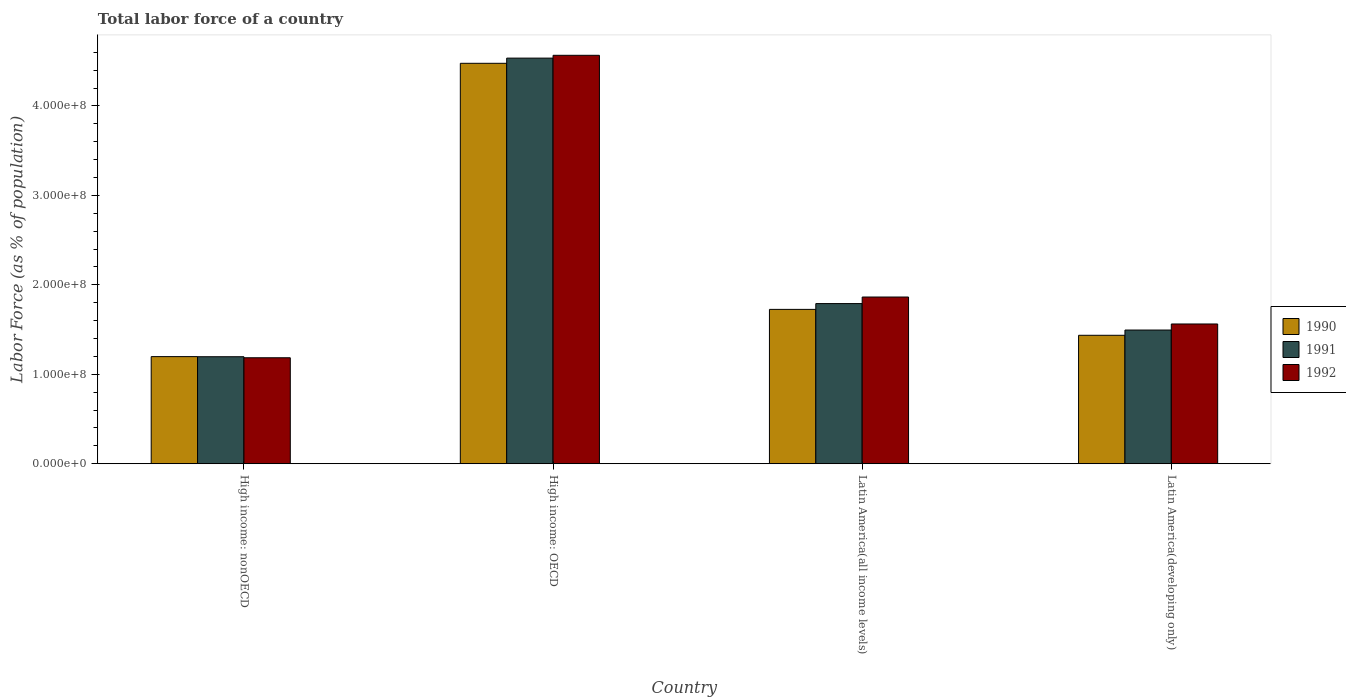How many groups of bars are there?
Your answer should be compact. 4. Are the number of bars per tick equal to the number of legend labels?
Provide a succinct answer. Yes. Are the number of bars on each tick of the X-axis equal?
Your answer should be compact. Yes. What is the label of the 1st group of bars from the left?
Your response must be concise. High income: nonOECD. What is the percentage of labor force in 1992 in Latin America(all income levels)?
Ensure brevity in your answer.  1.86e+08. Across all countries, what is the maximum percentage of labor force in 1990?
Offer a very short reply. 4.48e+08. Across all countries, what is the minimum percentage of labor force in 1992?
Provide a short and direct response. 1.18e+08. In which country was the percentage of labor force in 1991 maximum?
Ensure brevity in your answer.  High income: OECD. In which country was the percentage of labor force in 1992 minimum?
Offer a very short reply. High income: nonOECD. What is the total percentage of labor force in 1992 in the graph?
Ensure brevity in your answer.  9.18e+08. What is the difference between the percentage of labor force in 1991 in High income: OECD and that in Latin America(developing only)?
Keep it short and to the point. 3.04e+08. What is the difference between the percentage of labor force in 1990 in Latin America(all income levels) and the percentage of labor force in 1991 in High income: OECD?
Your answer should be very brief. -2.81e+08. What is the average percentage of labor force in 1991 per country?
Give a very brief answer. 2.25e+08. What is the difference between the percentage of labor force of/in 1991 and percentage of labor force of/in 1992 in High income: OECD?
Ensure brevity in your answer.  -3.15e+06. What is the ratio of the percentage of labor force in 1992 in Latin America(all income levels) to that in Latin America(developing only)?
Your answer should be compact. 1.19. Is the percentage of labor force in 1990 in High income: nonOECD less than that in Latin America(all income levels)?
Your answer should be very brief. Yes. What is the difference between the highest and the second highest percentage of labor force in 1991?
Provide a succinct answer. 3.04e+08. What is the difference between the highest and the lowest percentage of labor force in 1990?
Your response must be concise. 3.28e+08. In how many countries, is the percentage of labor force in 1990 greater than the average percentage of labor force in 1990 taken over all countries?
Keep it short and to the point. 1. Is the sum of the percentage of labor force in 1990 in High income: nonOECD and Latin America(all income levels) greater than the maximum percentage of labor force in 1992 across all countries?
Give a very brief answer. No. What does the 2nd bar from the left in Latin America(developing only) represents?
Your answer should be very brief. 1991. What does the 3rd bar from the right in High income: OECD represents?
Provide a succinct answer. 1990. Is it the case that in every country, the sum of the percentage of labor force in 1990 and percentage of labor force in 1991 is greater than the percentage of labor force in 1992?
Your answer should be compact. Yes. How many bars are there?
Offer a very short reply. 12. Are all the bars in the graph horizontal?
Offer a very short reply. No. How many countries are there in the graph?
Offer a terse response. 4. Are the values on the major ticks of Y-axis written in scientific E-notation?
Provide a succinct answer. Yes. Where does the legend appear in the graph?
Your answer should be very brief. Center right. How many legend labels are there?
Offer a terse response. 3. What is the title of the graph?
Your response must be concise. Total labor force of a country. Does "1964" appear as one of the legend labels in the graph?
Offer a very short reply. No. What is the label or title of the X-axis?
Your answer should be very brief. Country. What is the label or title of the Y-axis?
Your response must be concise. Labor Force (as % of population). What is the Labor Force (as % of population) in 1990 in High income: nonOECD?
Offer a terse response. 1.20e+08. What is the Labor Force (as % of population) of 1991 in High income: nonOECD?
Give a very brief answer. 1.20e+08. What is the Labor Force (as % of population) of 1992 in High income: nonOECD?
Your response must be concise. 1.18e+08. What is the Labor Force (as % of population) in 1990 in High income: OECD?
Offer a very short reply. 4.48e+08. What is the Labor Force (as % of population) of 1991 in High income: OECD?
Your answer should be very brief. 4.53e+08. What is the Labor Force (as % of population) in 1992 in High income: OECD?
Your answer should be very brief. 4.57e+08. What is the Labor Force (as % of population) of 1990 in Latin America(all income levels)?
Ensure brevity in your answer.  1.73e+08. What is the Labor Force (as % of population) of 1991 in Latin America(all income levels)?
Offer a terse response. 1.79e+08. What is the Labor Force (as % of population) in 1992 in Latin America(all income levels)?
Provide a short and direct response. 1.86e+08. What is the Labor Force (as % of population) of 1990 in Latin America(developing only)?
Your answer should be very brief. 1.44e+08. What is the Labor Force (as % of population) in 1991 in Latin America(developing only)?
Make the answer very short. 1.49e+08. What is the Labor Force (as % of population) in 1992 in Latin America(developing only)?
Keep it short and to the point. 1.56e+08. Across all countries, what is the maximum Labor Force (as % of population) in 1990?
Ensure brevity in your answer.  4.48e+08. Across all countries, what is the maximum Labor Force (as % of population) of 1991?
Provide a succinct answer. 4.53e+08. Across all countries, what is the maximum Labor Force (as % of population) of 1992?
Your response must be concise. 4.57e+08. Across all countries, what is the minimum Labor Force (as % of population) of 1990?
Provide a short and direct response. 1.20e+08. Across all countries, what is the minimum Labor Force (as % of population) of 1991?
Give a very brief answer. 1.20e+08. Across all countries, what is the minimum Labor Force (as % of population) of 1992?
Keep it short and to the point. 1.18e+08. What is the total Labor Force (as % of population) in 1990 in the graph?
Provide a succinct answer. 8.84e+08. What is the total Labor Force (as % of population) of 1991 in the graph?
Give a very brief answer. 9.02e+08. What is the total Labor Force (as % of population) of 1992 in the graph?
Your answer should be compact. 9.18e+08. What is the difference between the Labor Force (as % of population) in 1990 in High income: nonOECD and that in High income: OECD?
Offer a very short reply. -3.28e+08. What is the difference between the Labor Force (as % of population) in 1991 in High income: nonOECD and that in High income: OECD?
Provide a short and direct response. -3.34e+08. What is the difference between the Labor Force (as % of population) of 1992 in High income: nonOECD and that in High income: OECD?
Your response must be concise. -3.38e+08. What is the difference between the Labor Force (as % of population) of 1990 in High income: nonOECD and that in Latin America(all income levels)?
Your response must be concise. -5.28e+07. What is the difference between the Labor Force (as % of population) of 1991 in High income: nonOECD and that in Latin America(all income levels)?
Offer a very short reply. -5.94e+07. What is the difference between the Labor Force (as % of population) in 1992 in High income: nonOECD and that in Latin America(all income levels)?
Provide a succinct answer. -6.79e+07. What is the difference between the Labor Force (as % of population) in 1990 in High income: nonOECD and that in Latin America(developing only)?
Offer a very short reply. -2.38e+07. What is the difference between the Labor Force (as % of population) in 1991 in High income: nonOECD and that in Latin America(developing only)?
Your answer should be compact. -2.98e+07. What is the difference between the Labor Force (as % of population) in 1992 in High income: nonOECD and that in Latin America(developing only)?
Your answer should be compact. -3.78e+07. What is the difference between the Labor Force (as % of population) of 1990 in High income: OECD and that in Latin America(all income levels)?
Your answer should be compact. 2.75e+08. What is the difference between the Labor Force (as % of population) in 1991 in High income: OECD and that in Latin America(all income levels)?
Your response must be concise. 2.74e+08. What is the difference between the Labor Force (as % of population) in 1992 in High income: OECD and that in Latin America(all income levels)?
Your response must be concise. 2.70e+08. What is the difference between the Labor Force (as % of population) of 1990 in High income: OECD and that in Latin America(developing only)?
Ensure brevity in your answer.  3.04e+08. What is the difference between the Labor Force (as % of population) in 1991 in High income: OECD and that in Latin America(developing only)?
Ensure brevity in your answer.  3.04e+08. What is the difference between the Labor Force (as % of population) of 1992 in High income: OECD and that in Latin America(developing only)?
Your response must be concise. 3.00e+08. What is the difference between the Labor Force (as % of population) in 1990 in Latin America(all income levels) and that in Latin America(developing only)?
Make the answer very short. 2.90e+07. What is the difference between the Labor Force (as % of population) of 1991 in Latin America(all income levels) and that in Latin America(developing only)?
Provide a succinct answer. 2.96e+07. What is the difference between the Labor Force (as % of population) in 1992 in Latin America(all income levels) and that in Latin America(developing only)?
Your answer should be compact. 3.01e+07. What is the difference between the Labor Force (as % of population) in 1990 in High income: nonOECD and the Labor Force (as % of population) in 1991 in High income: OECD?
Offer a terse response. -3.34e+08. What is the difference between the Labor Force (as % of population) of 1990 in High income: nonOECD and the Labor Force (as % of population) of 1992 in High income: OECD?
Ensure brevity in your answer.  -3.37e+08. What is the difference between the Labor Force (as % of population) in 1991 in High income: nonOECD and the Labor Force (as % of population) in 1992 in High income: OECD?
Provide a short and direct response. -3.37e+08. What is the difference between the Labor Force (as % of population) of 1990 in High income: nonOECD and the Labor Force (as % of population) of 1991 in Latin America(all income levels)?
Your answer should be very brief. -5.93e+07. What is the difference between the Labor Force (as % of population) of 1990 in High income: nonOECD and the Labor Force (as % of population) of 1992 in Latin America(all income levels)?
Your answer should be very brief. -6.66e+07. What is the difference between the Labor Force (as % of population) of 1991 in High income: nonOECD and the Labor Force (as % of population) of 1992 in Latin America(all income levels)?
Your response must be concise. -6.67e+07. What is the difference between the Labor Force (as % of population) of 1990 in High income: nonOECD and the Labor Force (as % of population) of 1991 in Latin America(developing only)?
Offer a very short reply. -2.97e+07. What is the difference between the Labor Force (as % of population) of 1990 in High income: nonOECD and the Labor Force (as % of population) of 1992 in Latin America(developing only)?
Keep it short and to the point. -3.65e+07. What is the difference between the Labor Force (as % of population) in 1991 in High income: nonOECD and the Labor Force (as % of population) in 1992 in Latin America(developing only)?
Make the answer very short. -3.66e+07. What is the difference between the Labor Force (as % of population) of 1990 in High income: OECD and the Labor Force (as % of population) of 1991 in Latin America(all income levels)?
Provide a succinct answer. 2.69e+08. What is the difference between the Labor Force (as % of population) of 1990 in High income: OECD and the Labor Force (as % of population) of 1992 in Latin America(all income levels)?
Provide a succinct answer. 2.61e+08. What is the difference between the Labor Force (as % of population) in 1991 in High income: OECD and the Labor Force (as % of population) in 1992 in Latin America(all income levels)?
Provide a short and direct response. 2.67e+08. What is the difference between the Labor Force (as % of population) of 1990 in High income: OECD and the Labor Force (as % of population) of 1991 in Latin America(developing only)?
Offer a very short reply. 2.98e+08. What is the difference between the Labor Force (as % of population) of 1990 in High income: OECD and the Labor Force (as % of population) of 1992 in Latin America(developing only)?
Keep it short and to the point. 2.91e+08. What is the difference between the Labor Force (as % of population) in 1991 in High income: OECD and the Labor Force (as % of population) in 1992 in Latin America(developing only)?
Your response must be concise. 2.97e+08. What is the difference between the Labor Force (as % of population) of 1990 in Latin America(all income levels) and the Labor Force (as % of population) of 1991 in Latin America(developing only)?
Give a very brief answer. 2.31e+07. What is the difference between the Labor Force (as % of population) of 1990 in Latin America(all income levels) and the Labor Force (as % of population) of 1992 in Latin America(developing only)?
Provide a succinct answer. 1.63e+07. What is the difference between the Labor Force (as % of population) in 1991 in Latin America(all income levels) and the Labor Force (as % of population) in 1992 in Latin America(developing only)?
Offer a terse response. 2.28e+07. What is the average Labor Force (as % of population) in 1990 per country?
Your response must be concise. 2.21e+08. What is the average Labor Force (as % of population) in 1991 per country?
Provide a succinct answer. 2.25e+08. What is the average Labor Force (as % of population) in 1992 per country?
Make the answer very short. 2.29e+08. What is the difference between the Labor Force (as % of population) of 1990 and Labor Force (as % of population) of 1991 in High income: nonOECD?
Your response must be concise. 1.23e+05. What is the difference between the Labor Force (as % of population) in 1990 and Labor Force (as % of population) in 1992 in High income: nonOECD?
Make the answer very short. 1.27e+06. What is the difference between the Labor Force (as % of population) of 1991 and Labor Force (as % of population) of 1992 in High income: nonOECD?
Provide a short and direct response. 1.15e+06. What is the difference between the Labor Force (as % of population) in 1990 and Labor Force (as % of population) in 1991 in High income: OECD?
Ensure brevity in your answer.  -5.80e+06. What is the difference between the Labor Force (as % of population) of 1990 and Labor Force (as % of population) of 1992 in High income: OECD?
Provide a succinct answer. -8.94e+06. What is the difference between the Labor Force (as % of population) of 1991 and Labor Force (as % of population) of 1992 in High income: OECD?
Provide a succinct answer. -3.15e+06. What is the difference between the Labor Force (as % of population) of 1990 and Labor Force (as % of population) of 1991 in Latin America(all income levels)?
Your answer should be compact. -6.48e+06. What is the difference between the Labor Force (as % of population) of 1990 and Labor Force (as % of population) of 1992 in Latin America(all income levels)?
Offer a very short reply. -1.38e+07. What is the difference between the Labor Force (as % of population) of 1991 and Labor Force (as % of population) of 1992 in Latin America(all income levels)?
Give a very brief answer. -7.34e+06. What is the difference between the Labor Force (as % of population) of 1990 and Labor Force (as % of population) of 1991 in Latin America(developing only)?
Keep it short and to the point. -5.88e+06. What is the difference between the Labor Force (as % of population) in 1990 and Labor Force (as % of population) in 1992 in Latin America(developing only)?
Offer a terse response. -1.26e+07. What is the difference between the Labor Force (as % of population) of 1991 and Labor Force (as % of population) of 1992 in Latin America(developing only)?
Your answer should be compact. -6.77e+06. What is the ratio of the Labor Force (as % of population) of 1990 in High income: nonOECD to that in High income: OECD?
Make the answer very short. 0.27. What is the ratio of the Labor Force (as % of population) in 1991 in High income: nonOECD to that in High income: OECD?
Provide a succinct answer. 0.26. What is the ratio of the Labor Force (as % of population) in 1992 in High income: nonOECD to that in High income: OECD?
Your answer should be compact. 0.26. What is the ratio of the Labor Force (as % of population) of 1990 in High income: nonOECD to that in Latin America(all income levels)?
Give a very brief answer. 0.69. What is the ratio of the Labor Force (as % of population) in 1991 in High income: nonOECD to that in Latin America(all income levels)?
Your response must be concise. 0.67. What is the ratio of the Labor Force (as % of population) of 1992 in High income: nonOECD to that in Latin America(all income levels)?
Your answer should be compact. 0.64. What is the ratio of the Labor Force (as % of population) of 1990 in High income: nonOECD to that in Latin America(developing only)?
Your answer should be compact. 0.83. What is the ratio of the Labor Force (as % of population) in 1991 in High income: nonOECD to that in Latin America(developing only)?
Give a very brief answer. 0.8. What is the ratio of the Labor Force (as % of population) in 1992 in High income: nonOECD to that in Latin America(developing only)?
Keep it short and to the point. 0.76. What is the ratio of the Labor Force (as % of population) of 1990 in High income: OECD to that in Latin America(all income levels)?
Offer a very short reply. 2.59. What is the ratio of the Labor Force (as % of population) in 1991 in High income: OECD to that in Latin America(all income levels)?
Keep it short and to the point. 2.53. What is the ratio of the Labor Force (as % of population) in 1992 in High income: OECD to that in Latin America(all income levels)?
Your answer should be compact. 2.45. What is the ratio of the Labor Force (as % of population) in 1990 in High income: OECD to that in Latin America(developing only)?
Provide a short and direct response. 3.12. What is the ratio of the Labor Force (as % of population) in 1991 in High income: OECD to that in Latin America(developing only)?
Your response must be concise. 3.03. What is the ratio of the Labor Force (as % of population) in 1992 in High income: OECD to that in Latin America(developing only)?
Your response must be concise. 2.92. What is the ratio of the Labor Force (as % of population) of 1990 in Latin America(all income levels) to that in Latin America(developing only)?
Your answer should be compact. 1.2. What is the ratio of the Labor Force (as % of population) of 1991 in Latin America(all income levels) to that in Latin America(developing only)?
Provide a succinct answer. 1.2. What is the ratio of the Labor Force (as % of population) in 1992 in Latin America(all income levels) to that in Latin America(developing only)?
Your response must be concise. 1.19. What is the difference between the highest and the second highest Labor Force (as % of population) of 1990?
Ensure brevity in your answer.  2.75e+08. What is the difference between the highest and the second highest Labor Force (as % of population) of 1991?
Make the answer very short. 2.74e+08. What is the difference between the highest and the second highest Labor Force (as % of population) in 1992?
Provide a short and direct response. 2.70e+08. What is the difference between the highest and the lowest Labor Force (as % of population) of 1990?
Provide a succinct answer. 3.28e+08. What is the difference between the highest and the lowest Labor Force (as % of population) of 1991?
Your answer should be compact. 3.34e+08. What is the difference between the highest and the lowest Labor Force (as % of population) of 1992?
Provide a succinct answer. 3.38e+08. 